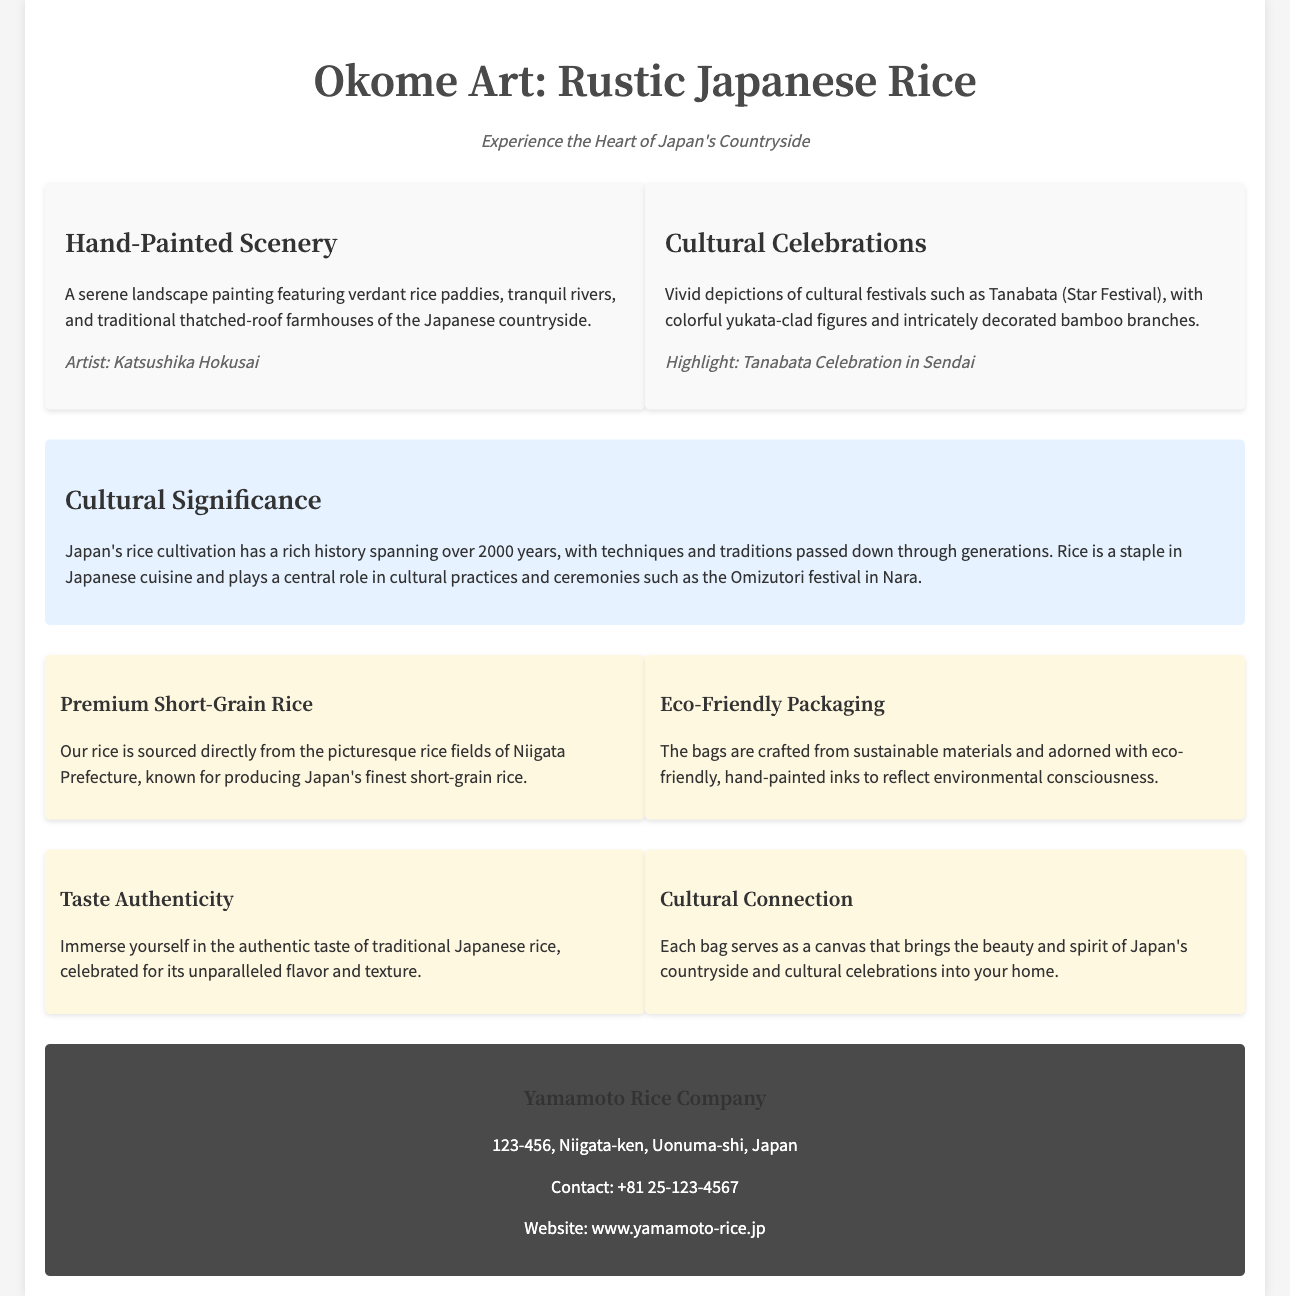What is the name of the product? The name of the product is stated in the title of the document as "Okome Art: Rustic Japanese Rice."
Answer: Okome Art: Rustic Japanese Rice Who is the artist of the hand-painted scenery? The document mentions that the artist of the hand-painted scenery is Katsushika Hokusai.
Answer: Katsushika Hokusai What is highlighted in the cultural celebrations section? The cultural celebrations section highlights the Tanabata Celebration in Sendai.
Answer: Tanabata Celebration in Sendai What is the main ingredient of the rice? The document describes the rice as premium short-grain rice sourced from Niigata Prefecture.
Answer: Premium short-grain rice What is the emphasis of the Eco-Friendly Packaging feature? The Eco-Friendly Packaging feature emphasizes that the bags are crafted from sustainable materials and adorned with eco-friendly inks.
Answer: Sustainable materials and eco-friendly inks What role does rice play in Japanese culture according to the document? The document explains that rice plays a central role in cultural practices and ceremonies in Japan.
Answer: Central role in cultural practices How long has rice cultivation existed in Japan? The document mentions that Japan's rice cultivation has a history spanning over 2000 years.
Answer: Over 2000 years What company produces this rice? The footer provides the name of the company as Yamamoto Rice Company.
Answer: Yamamoto Rice Company What is the contact number for the company? The contact information in the footer provides +81 25-123-4567 as the company's contact number.
Answer: +81 25-123-4567 